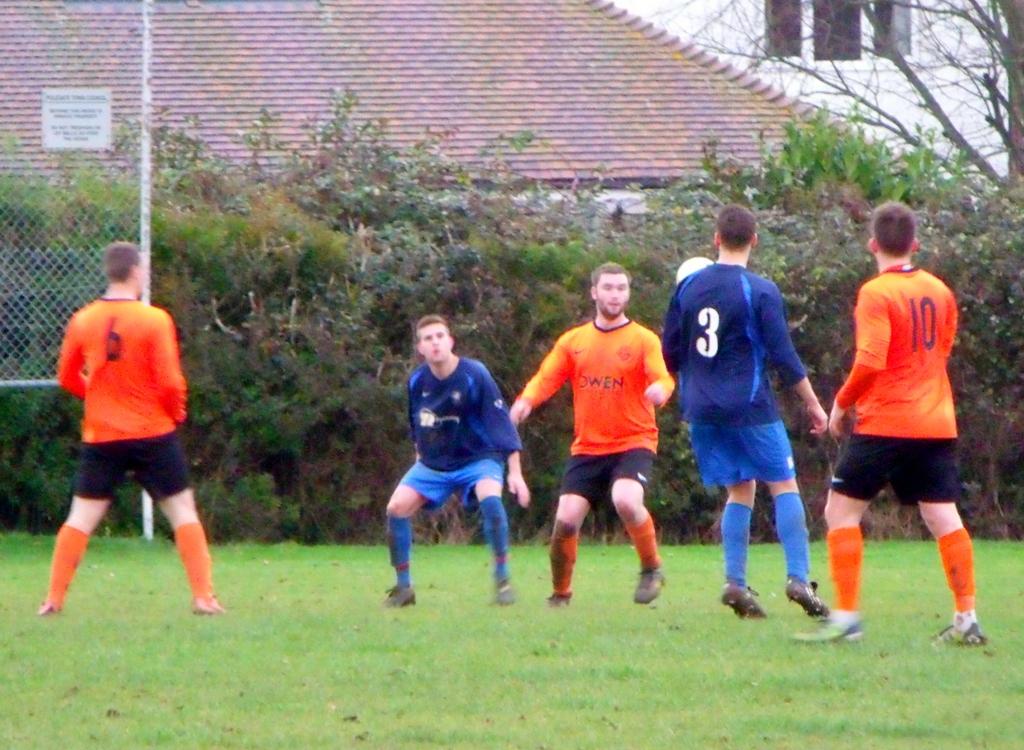What number is the player on the far right?
Your response must be concise. 10. What number is the player on the far left?
Offer a very short reply. 6. 